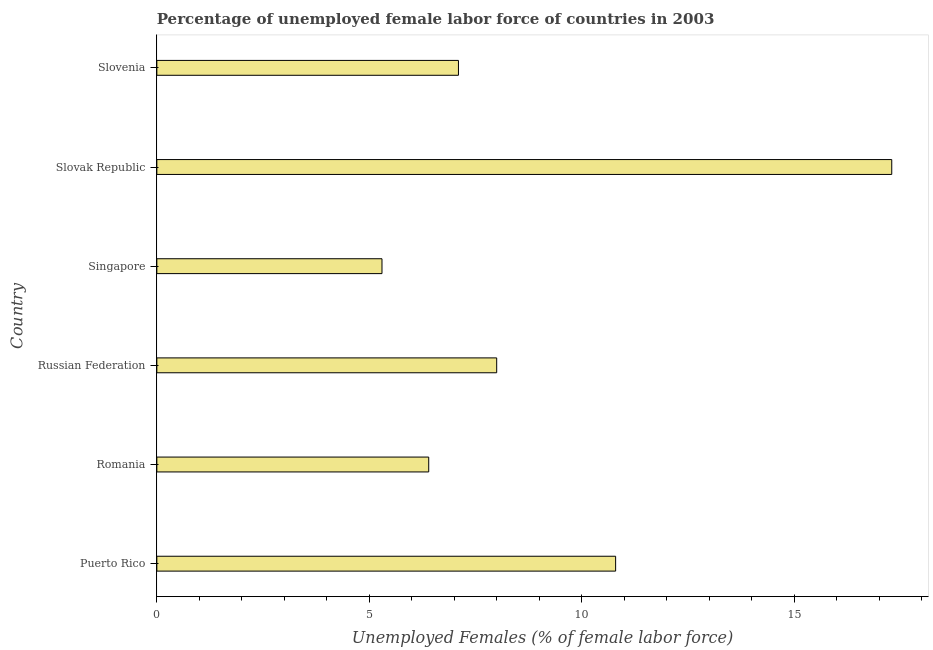Does the graph contain any zero values?
Provide a short and direct response. No. What is the title of the graph?
Offer a terse response. Percentage of unemployed female labor force of countries in 2003. What is the label or title of the X-axis?
Your answer should be compact. Unemployed Females (% of female labor force). What is the total unemployed female labour force in Slovak Republic?
Offer a very short reply. 17.3. Across all countries, what is the maximum total unemployed female labour force?
Make the answer very short. 17.3. Across all countries, what is the minimum total unemployed female labour force?
Your answer should be very brief. 5.3. In which country was the total unemployed female labour force maximum?
Provide a succinct answer. Slovak Republic. In which country was the total unemployed female labour force minimum?
Offer a very short reply. Singapore. What is the sum of the total unemployed female labour force?
Keep it short and to the point. 54.9. What is the average total unemployed female labour force per country?
Offer a very short reply. 9.15. What is the median total unemployed female labour force?
Provide a short and direct response. 7.55. In how many countries, is the total unemployed female labour force greater than 3 %?
Ensure brevity in your answer.  6. What is the ratio of the total unemployed female labour force in Romania to that in Singapore?
Your answer should be compact. 1.21. Is the difference between the total unemployed female labour force in Puerto Rico and Romania greater than the difference between any two countries?
Offer a terse response. No. What is the difference between the highest and the lowest total unemployed female labour force?
Your answer should be very brief. 12. Are all the bars in the graph horizontal?
Keep it short and to the point. Yes. How many countries are there in the graph?
Provide a short and direct response. 6. What is the difference between two consecutive major ticks on the X-axis?
Your answer should be compact. 5. What is the Unemployed Females (% of female labor force) of Puerto Rico?
Give a very brief answer. 10.8. What is the Unemployed Females (% of female labor force) of Romania?
Your response must be concise. 6.4. What is the Unemployed Females (% of female labor force) in Russian Federation?
Your response must be concise. 8. What is the Unemployed Females (% of female labor force) in Singapore?
Your response must be concise. 5.3. What is the Unemployed Females (% of female labor force) of Slovak Republic?
Keep it short and to the point. 17.3. What is the Unemployed Females (% of female labor force) of Slovenia?
Provide a succinct answer. 7.1. What is the difference between the Unemployed Females (% of female labor force) in Puerto Rico and Romania?
Keep it short and to the point. 4.4. What is the difference between the Unemployed Females (% of female labor force) in Puerto Rico and Russian Federation?
Make the answer very short. 2.8. What is the difference between the Unemployed Females (% of female labor force) in Puerto Rico and Slovak Republic?
Make the answer very short. -6.5. What is the difference between the Unemployed Females (% of female labor force) in Puerto Rico and Slovenia?
Offer a terse response. 3.7. What is the difference between the Unemployed Females (% of female labor force) in Romania and Singapore?
Keep it short and to the point. 1.1. What is the difference between the Unemployed Females (% of female labor force) in Romania and Slovak Republic?
Provide a succinct answer. -10.9. What is the difference between the Unemployed Females (% of female labor force) in Romania and Slovenia?
Provide a succinct answer. -0.7. What is the difference between the Unemployed Females (% of female labor force) in Russian Federation and Singapore?
Your response must be concise. 2.7. What is the difference between the Unemployed Females (% of female labor force) in Russian Federation and Slovenia?
Provide a short and direct response. 0.9. What is the difference between the Unemployed Females (% of female labor force) in Singapore and Slovak Republic?
Make the answer very short. -12. What is the difference between the Unemployed Females (% of female labor force) in Singapore and Slovenia?
Give a very brief answer. -1.8. What is the difference between the Unemployed Females (% of female labor force) in Slovak Republic and Slovenia?
Offer a very short reply. 10.2. What is the ratio of the Unemployed Females (% of female labor force) in Puerto Rico to that in Romania?
Offer a terse response. 1.69. What is the ratio of the Unemployed Females (% of female labor force) in Puerto Rico to that in Russian Federation?
Provide a short and direct response. 1.35. What is the ratio of the Unemployed Females (% of female labor force) in Puerto Rico to that in Singapore?
Provide a succinct answer. 2.04. What is the ratio of the Unemployed Females (% of female labor force) in Puerto Rico to that in Slovak Republic?
Make the answer very short. 0.62. What is the ratio of the Unemployed Females (% of female labor force) in Puerto Rico to that in Slovenia?
Provide a succinct answer. 1.52. What is the ratio of the Unemployed Females (% of female labor force) in Romania to that in Singapore?
Your answer should be very brief. 1.21. What is the ratio of the Unemployed Females (% of female labor force) in Romania to that in Slovak Republic?
Offer a very short reply. 0.37. What is the ratio of the Unemployed Females (% of female labor force) in Romania to that in Slovenia?
Your answer should be very brief. 0.9. What is the ratio of the Unemployed Females (% of female labor force) in Russian Federation to that in Singapore?
Offer a very short reply. 1.51. What is the ratio of the Unemployed Females (% of female labor force) in Russian Federation to that in Slovak Republic?
Your response must be concise. 0.46. What is the ratio of the Unemployed Females (% of female labor force) in Russian Federation to that in Slovenia?
Provide a succinct answer. 1.13. What is the ratio of the Unemployed Females (% of female labor force) in Singapore to that in Slovak Republic?
Give a very brief answer. 0.31. What is the ratio of the Unemployed Females (% of female labor force) in Singapore to that in Slovenia?
Provide a succinct answer. 0.75. What is the ratio of the Unemployed Females (% of female labor force) in Slovak Republic to that in Slovenia?
Provide a short and direct response. 2.44. 